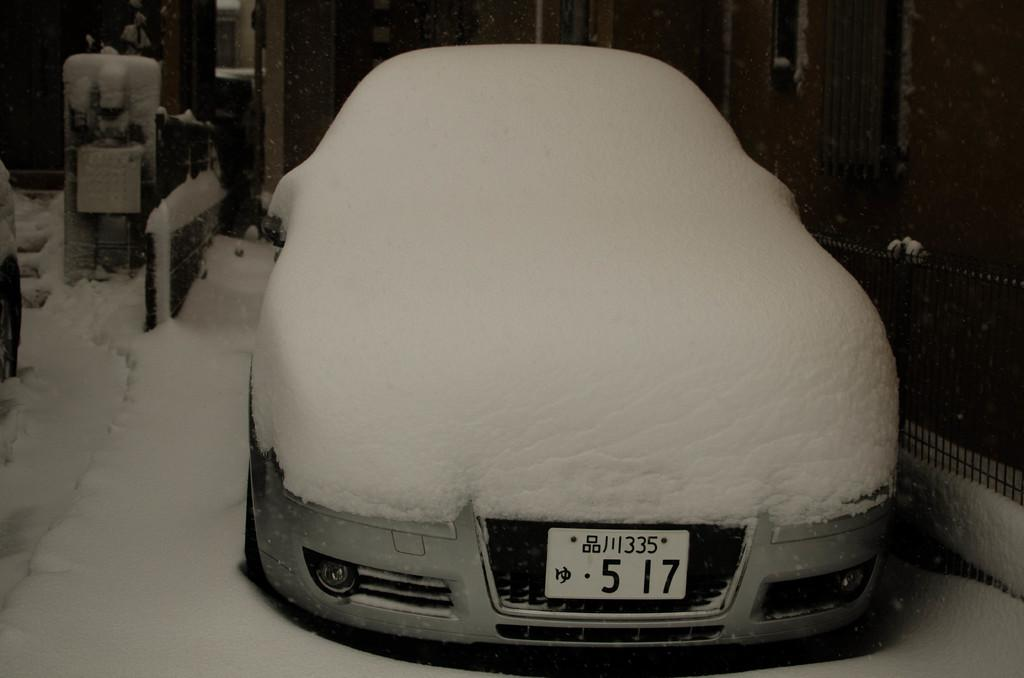<image>
Share a concise interpretation of the image provided. A snow covered car has the front licenses plate 517. 